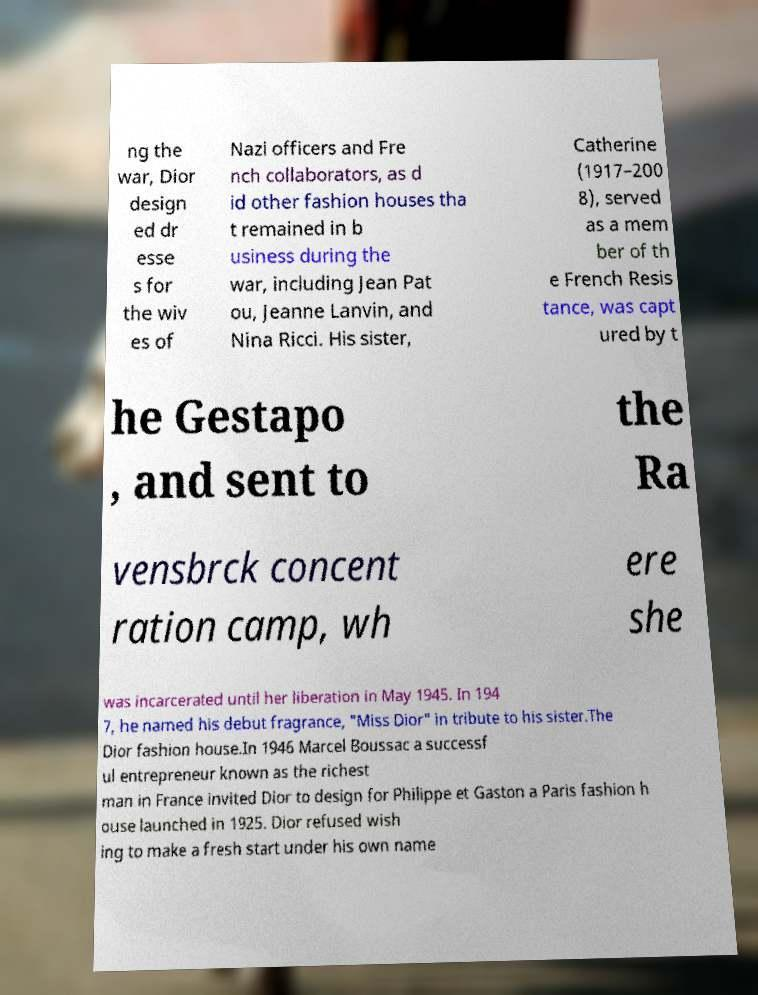Could you extract and type out the text from this image? ng the war, Dior design ed dr esse s for the wiv es of Nazi officers and Fre nch collaborators, as d id other fashion houses tha t remained in b usiness during the war, including Jean Pat ou, Jeanne Lanvin, and Nina Ricci. His sister, Catherine (1917–200 8), served as a mem ber of th e French Resis tance, was capt ured by t he Gestapo , and sent to the Ra vensbrck concent ration camp, wh ere she was incarcerated until her liberation in May 1945. In 194 7, he named his debut fragrance, "Miss Dior" in tribute to his sister.The Dior fashion house.In 1946 Marcel Boussac a successf ul entrepreneur known as the richest man in France invited Dior to design for Philippe et Gaston a Paris fashion h ouse launched in 1925. Dior refused wish ing to make a fresh start under his own name 